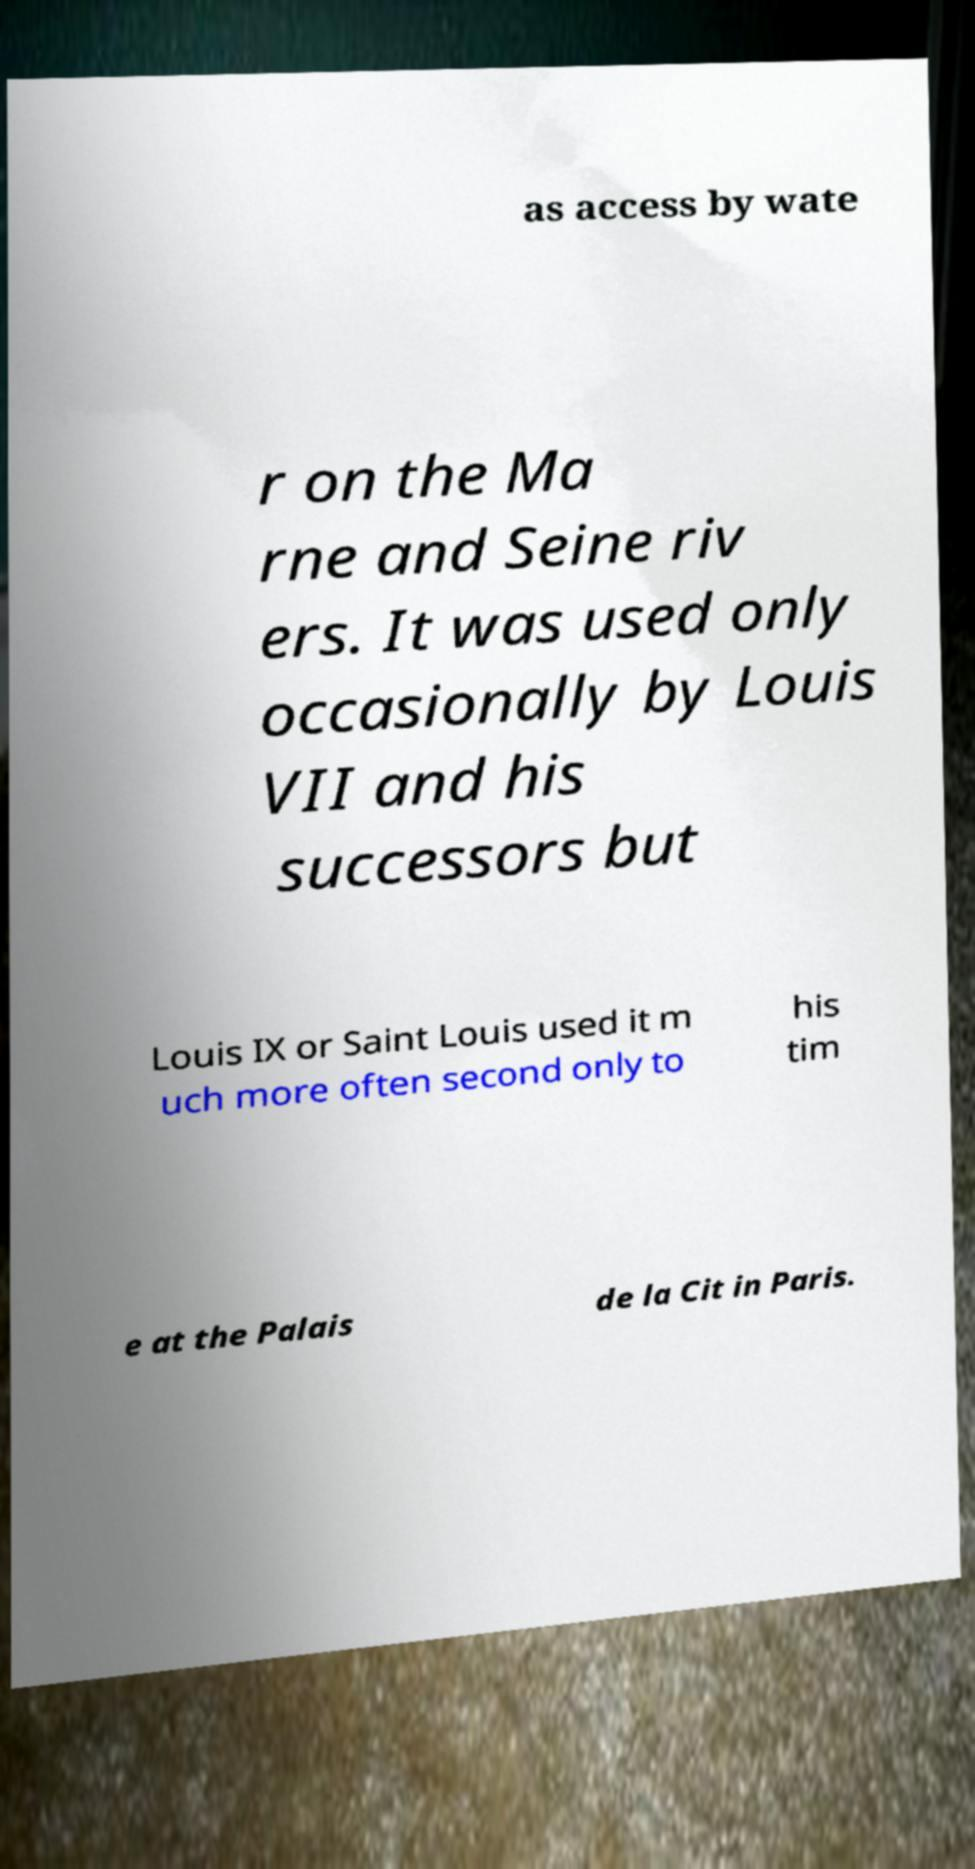Could you extract and type out the text from this image? as access by wate r on the Ma rne and Seine riv ers. It was used only occasionally by Louis VII and his successors but Louis IX or Saint Louis used it m uch more often second only to his tim e at the Palais de la Cit in Paris. 